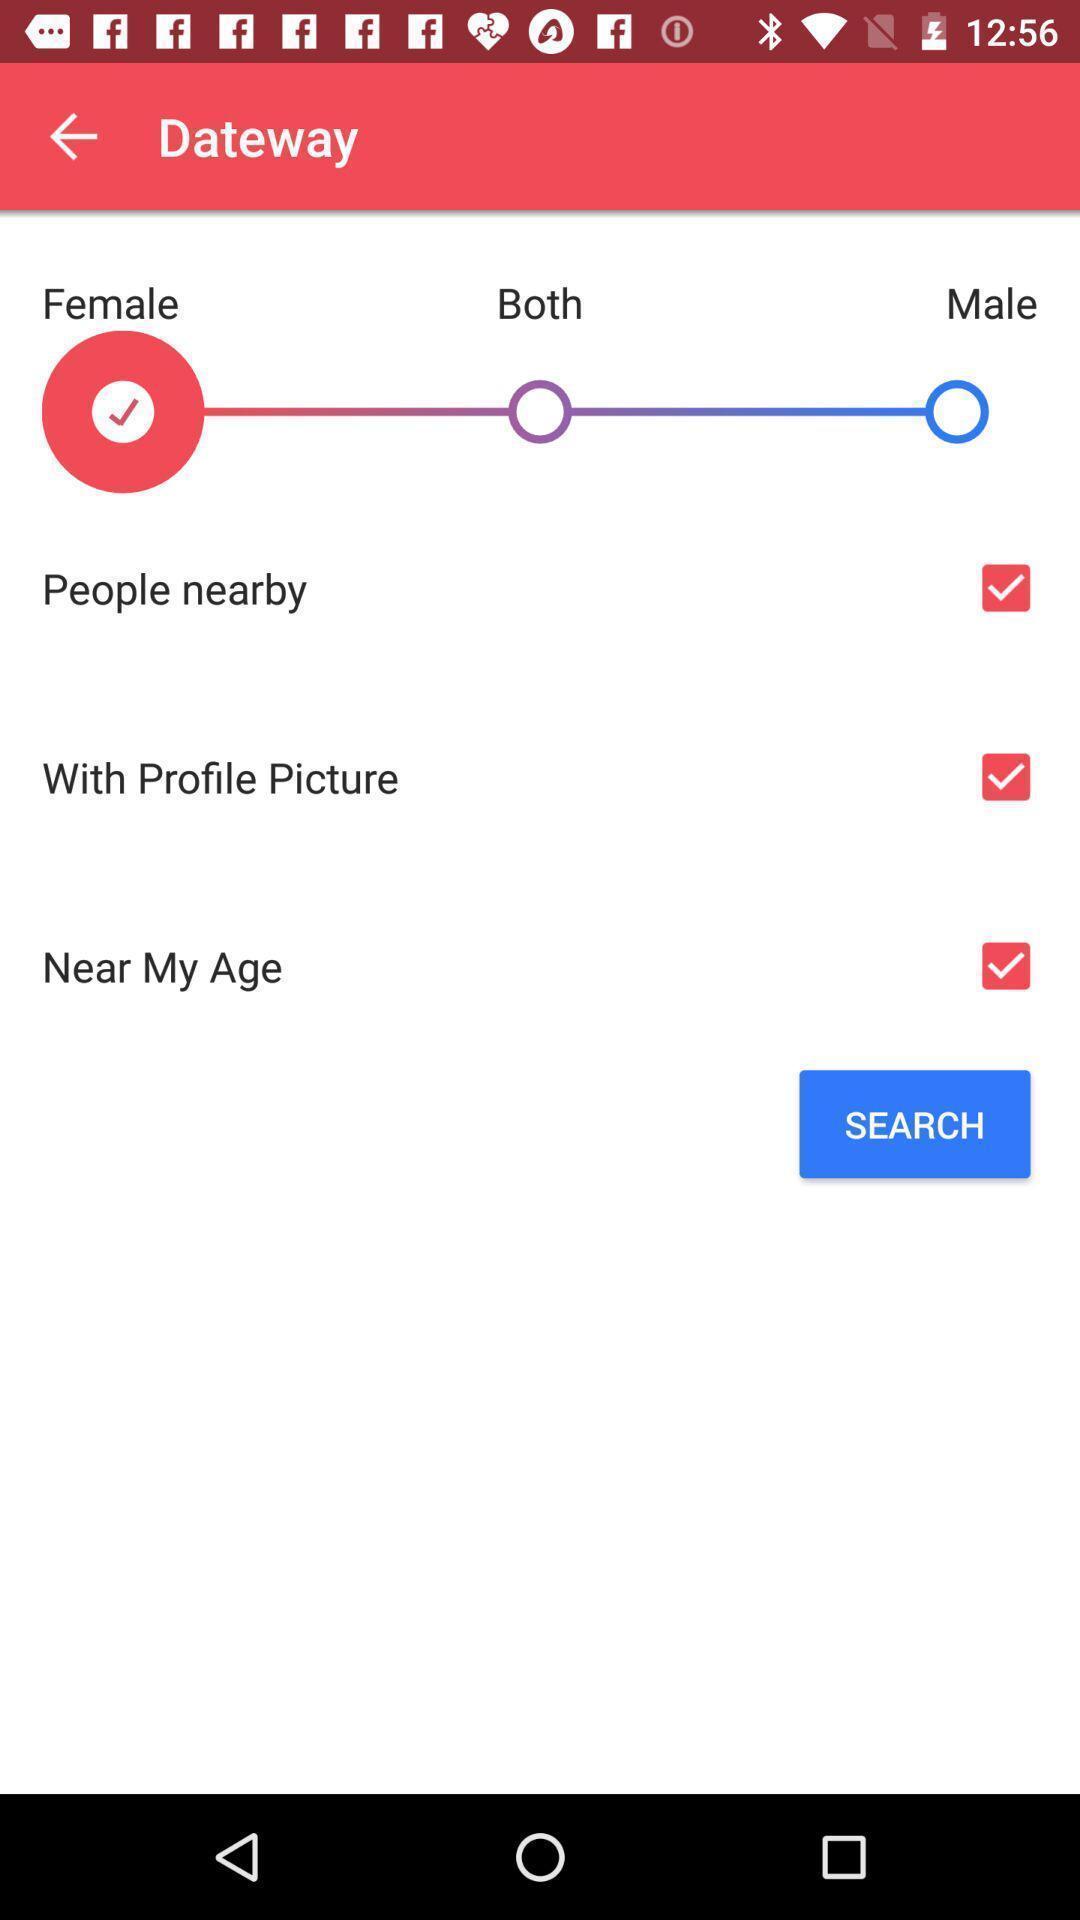Provide a description of this screenshot. Settings page displaying. 